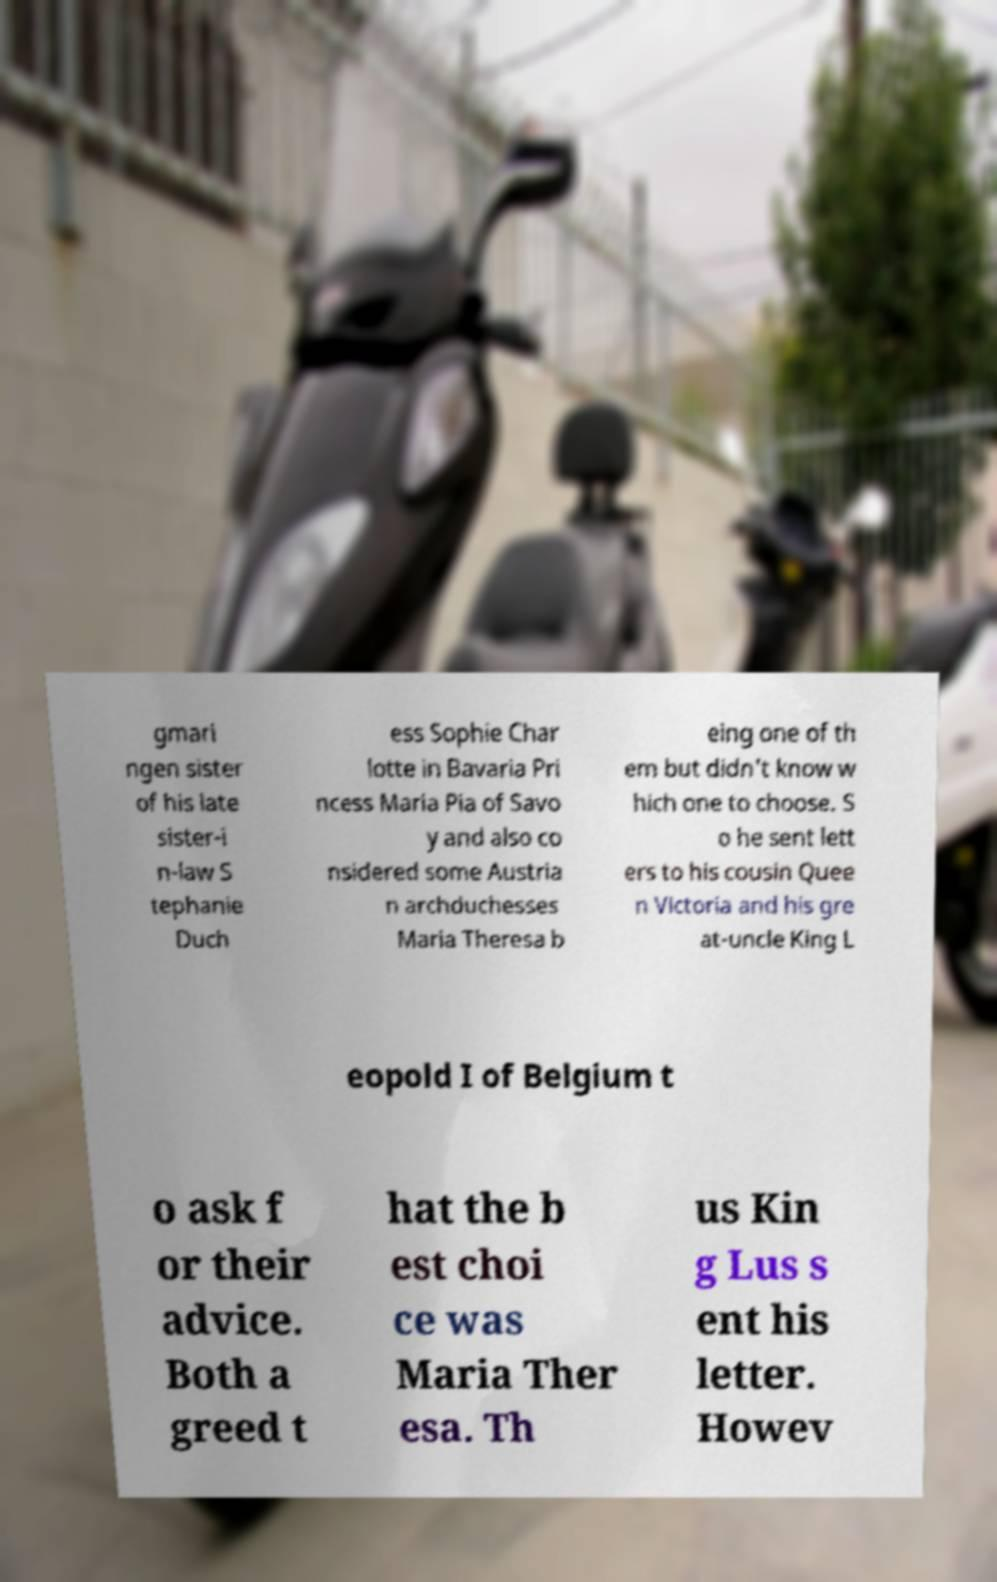What messages or text are displayed in this image? I need them in a readable, typed format. gmari ngen sister of his late sister-i n-law S tephanie Duch ess Sophie Char lotte in Bavaria Pri ncess Maria Pia of Savo y and also co nsidered some Austria n archduchesses Maria Theresa b eing one of th em but didn't know w hich one to choose. S o he sent lett ers to his cousin Quee n Victoria and his gre at-uncle King L eopold I of Belgium t o ask f or their advice. Both a greed t hat the b est choi ce was Maria Ther esa. Th us Kin g Lus s ent his letter. Howev 